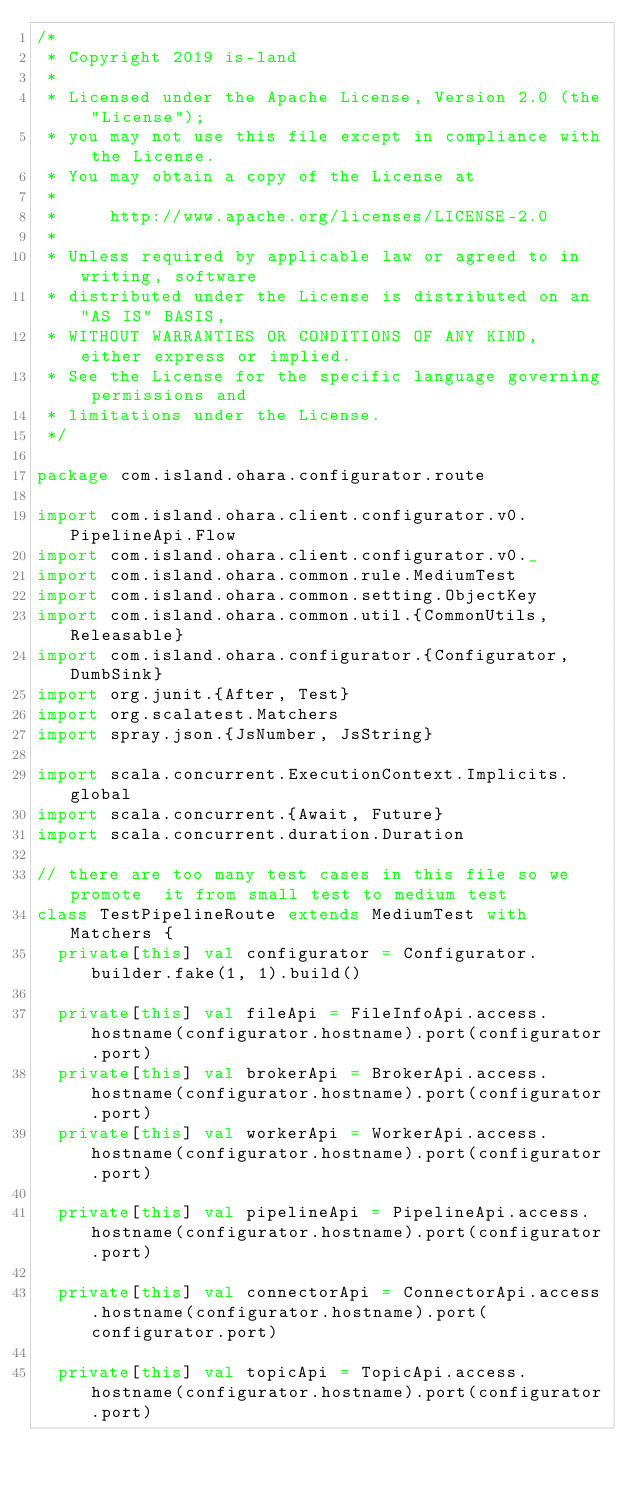Convert code to text. <code><loc_0><loc_0><loc_500><loc_500><_Scala_>/*
 * Copyright 2019 is-land
 *
 * Licensed under the Apache License, Version 2.0 (the "License");
 * you may not use this file except in compliance with the License.
 * You may obtain a copy of the License at
 *
 *     http://www.apache.org/licenses/LICENSE-2.0
 *
 * Unless required by applicable law or agreed to in writing, software
 * distributed under the License is distributed on an "AS IS" BASIS,
 * WITHOUT WARRANTIES OR CONDITIONS OF ANY KIND, either express or implied.
 * See the License for the specific language governing permissions and
 * limitations under the License.
 */

package com.island.ohara.configurator.route

import com.island.ohara.client.configurator.v0.PipelineApi.Flow
import com.island.ohara.client.configurator.v0._
import com.island.ohara.common.rule.MediumTest
import com.island.ohara.common.setting.ObjectKey
import com.island.ohara.common.util.{CommonUtils, Releasable}
import com.island.ohara.configurator.{Configurator, DumbSink}
import org.junit.{After, Test}
import org.scalatest.Matchers
import spray.json.{JsNumber, JsString}

import scala.concurrent.ExecutionContext.Implicits.global
import scala.concurrent.{Await, Future}
import scala.concurrent.duration.Duration

// there are too many test cases in this file so we promote  it from small test to medium test
class TestPipelineRoute extends MediumTest with Matchers {
  private[this] val configurator = Configurator.builder.fake(1, 1).build()

  private[this] val fileApi = FileInfoApi.access.hostname(configurator.hostname).port(configurator.port)
  private[this] val brokerApi = BrokerApi.access.hostname(configurator.hostname).port(configurator.port)
  private[this] val workerApi = WorkerApi.access.hostname(configurator.hostname).port(configurator.port)

  private[this] val pipelineApi = PipelineApi.access.hostname(configurator.hostname).port(configurator.port)

  private[this] val connectorApi = ConnectorApi.access.hostname(configurator.hostname).port(configurator.port)

  private[this] val topicApi = TopicApi.access.hostname(configurator.hostname).port(configurator.port)
</code> 